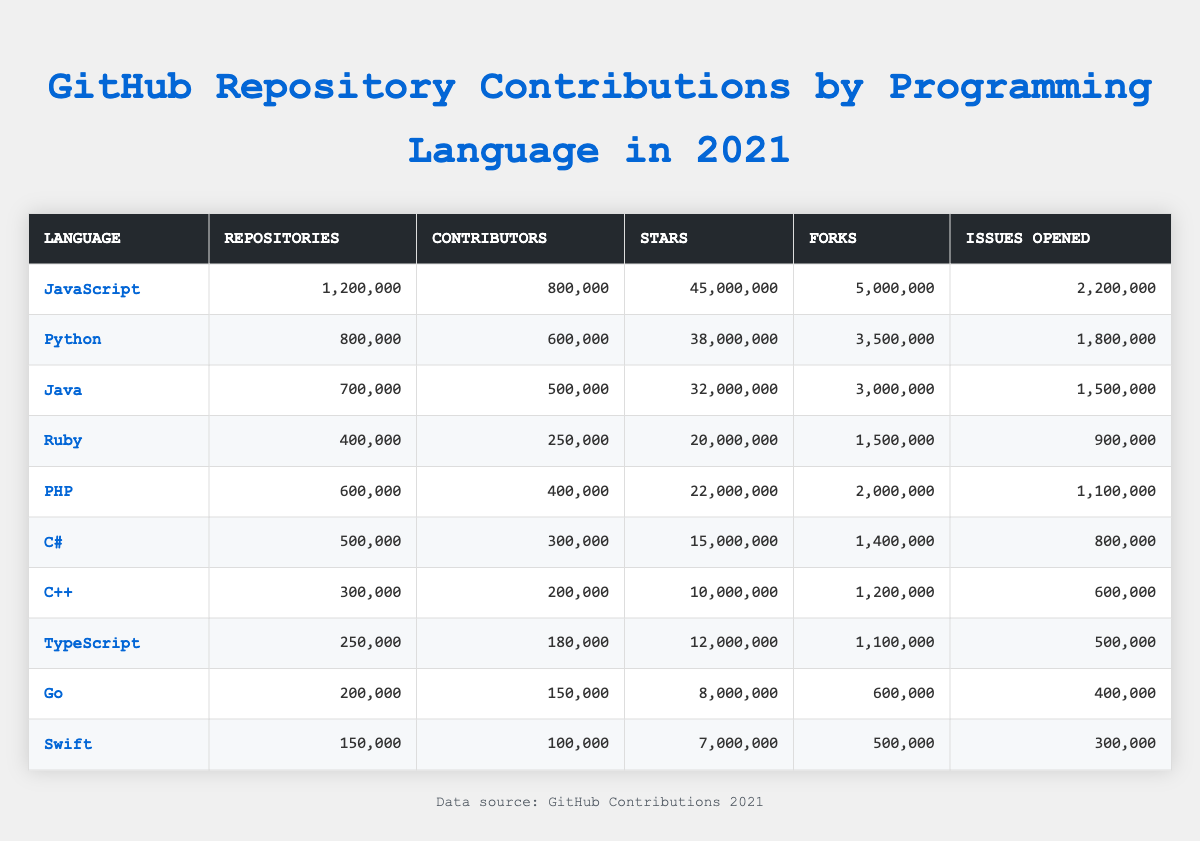What programming language has the highest number of contributors? By examining the "Contributors" column, JavaScript has the highest number with 800,000 contributors.
Answer: JavaScript How many repositories are there for Python? The table lists 800,000 repositories under the "Repositories" column for Python.
Answer: 800,000 Which language received the most stars in 2021? Looking at the "Stars" column, JavaScript received the most stars, with a total of 45,000,000.
Answer: JavaScript How many more forks does Java have than Swift? Java has 3,000,000 forks, while Swift has 500,000. The difference is 3,000,000 - 500,000 = 2,500,000.
Answer: 2,500,000 What is the average number of issues opened across all languages? To find the average, add all issues opened: 2,200,000 + 1,800,000 + 1,500,000 + 900,000 + 1,100,000 + 800,000 + 600,000 + 500,000 + 400,000 + 300,000 = 9,600,000. Then divide by 10, resulting in 9,600,000 / 10 = 960,000.
Answer: 960,000 Is the number of repositories for Ruby greater than that of C++? Ruby has 400,000 repositories and C++ has 300,000. Therefore, 400,000 is greater than 300,000, confirming the statement is true.
Answer: Yes How do the total stars for Go and Swift compare in 2021? Go has 8,000,000 stars and Swift has 7,000,000 stars. The difference is 8,000,000 - 7,000,000 = 1,000,000, indicating that Go has more.
Answer: Go has more stars by 1,000,000 Which programming language had the least number of contributors? By checking the "Contributors" column, it shows that Swift has the least with 100,000 contributors.
Answer: Swift If you combine the number of issues opened for PHP and C#, how many issues were opened in total? PHP has 1,100,000 issues and C# has 800,000 issues. Adding these gives: 1,100,000 + 800,000 = 1,900,000.
Answer: 1,900,000 What is the ratio of JavaScript repositories to Go repositories? JavaScript has 1,200,000 repositories and Go has 200,000 repositories. The ratio is 1,200,000 / 200,000 = 6, meaning there are 6 times more JavaScript repositories than Go.
Answer: 6:1 Which language has more forks, PHP or Ruby? PHP has 2,000,000 forks while Ruby has 1,500,000 forks. Since 2,000,000 > 1,500,000, PHP has more forks.
Answer: PHP has more forks 